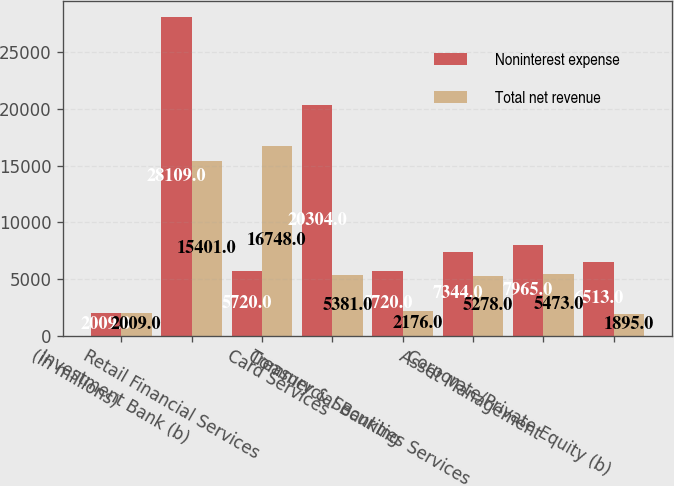Convert chart. <chart><loc_0><loc_0><loc_500><loc_500><stacked_bar_chart><ecel><fcel>(in millions)<fcel>Investment Bank (b)<fcel>Retail Financial Services<fcel>Card Services<fcel>Commercial Banking<fcel>Treasury & Securities Services<fcel>Asset Management<fcel>Corporate/Private Equity (b)<nl><fcel>Noninterest expense<fcel>2009<fcel>28109<fcel>5720<fcel>20304<fcel>5720<fcel>7344<fcel>7965<fcel>6513<nl><fcel>Total net revenue<fcel>2009<fcel>15401<fcel>16748<fcel>5381<fcel>2176<fcel>5278<fcel>5473<fcel>1895<nl></chart> 